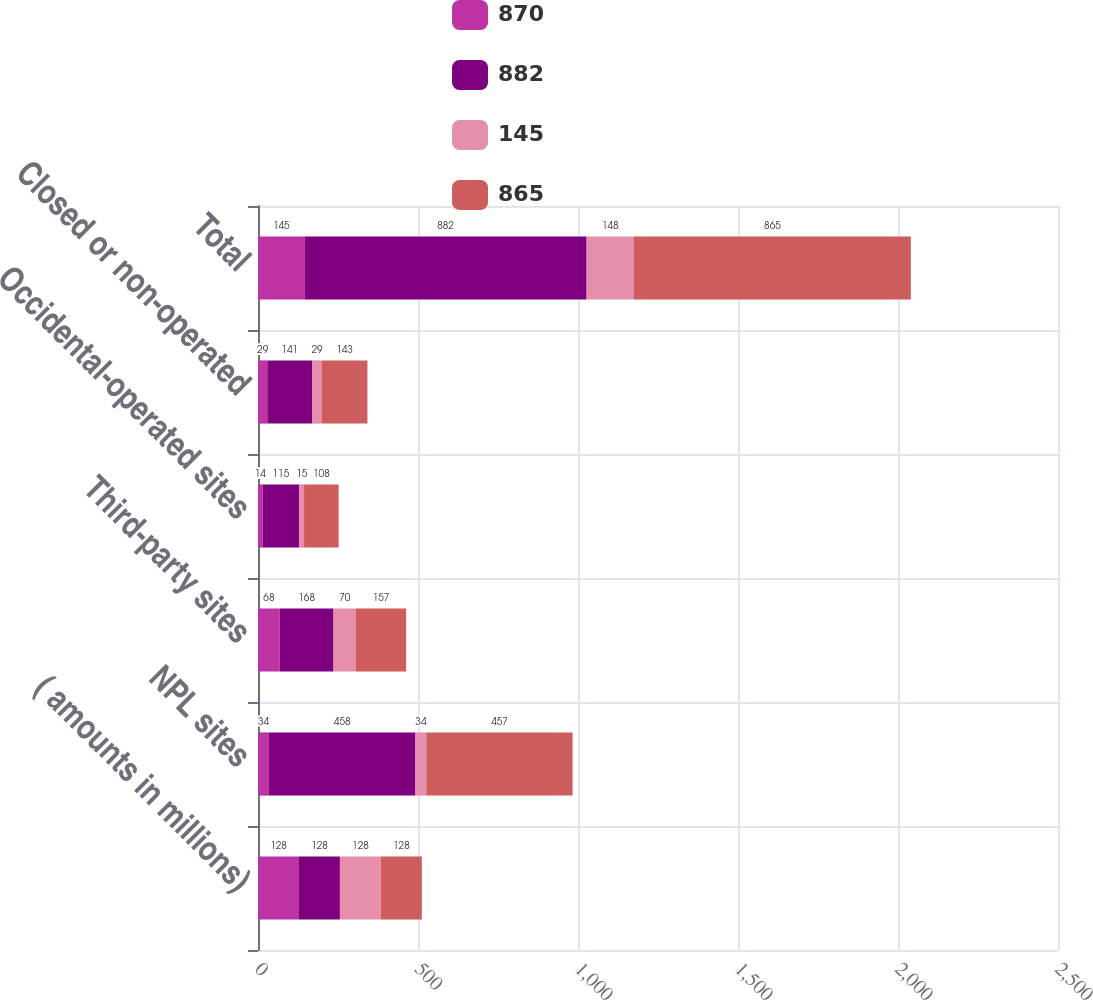<chart> <loc_0><loc_0><loc_500><loc_500><stacked_bar_chart><ecel><fcel>( amounts in millions)<fcel>NPL sites<fcel>Third-party sites<fcel>Occidental-operated sites<fcel>Closed or non-operated<fcel>Total<nl><fcel>870<fcel>128<fcel>34<fcel>68<fcel>14<fcel>29<fcel>145<nl><fcel>882<fcel>128<fcel>458<fcel>168<fcel>115<fcel>141<fcel>882<nl><fcel>145<fcel>128<fcel>34<fcel>70<fcel>15<fcel>29<fcel>148<nl><fcel>865<fcel>128<fcel>457<fcel>157<fcel>108<fcel>143<fcel>865<nl></chart> 